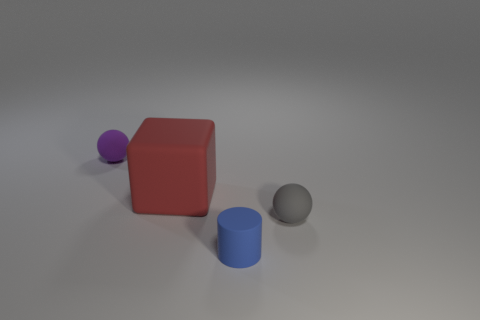Is the number of small blue cylinders less than the number of small metallic spheres?
Offer a terse response. No. How many red matte blocks are there?
Offer a very short reply. 1. Are there fewer small things that are to the left of the small purple object than blue cylinders?
Your response must be concise. Yes. Is the material of the tiny ball that is in front of the red rubber cube the same as the small purple ball?
Make the answer very short. Yes. What shape is the small gray matte object that is in front of the tiny rubber sphere behind the tiny ball that is right of the purple matte object?
Keep it short and to the point. Sphere. Is there a gray object that has the same size as the gray sphere?
Make the answer very short. No. The red object is what size?
Provide a succinct answer. Large. How many purple rubber spheres are the same size as the rubber cylinder?
Provide a short and direct response. 1. Are there fewer rubber spheres to the left of the red rubber cube than tiny matte cylinders in front of the small blue cylinder?
Your response must be concise. No. There is a matte ball that is behind the tiny sphere in front of the ball that is to the left of the gray rubber thing; what is its size?
Your answer should be compact. Small. 